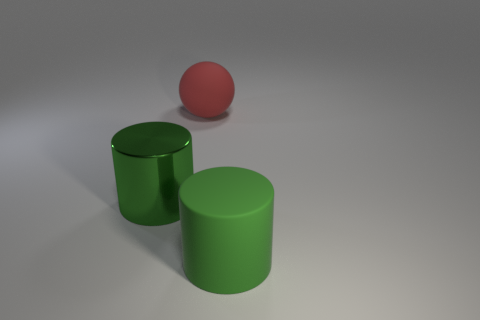Add 1 large brown metal cylinders. How many objects exist? 4 Subtract all balls. How many objects are left? 2 Add 1 big objects. How many big objects exist? 4 Subtract 0 cyan blocks. How many objects are left? 3 Subtract all big objects. Subtract all small blue matte cylinders. How many objects are left? 0 Add 2 green shiny cylinders. How many green shiny cylinders are left? 3 